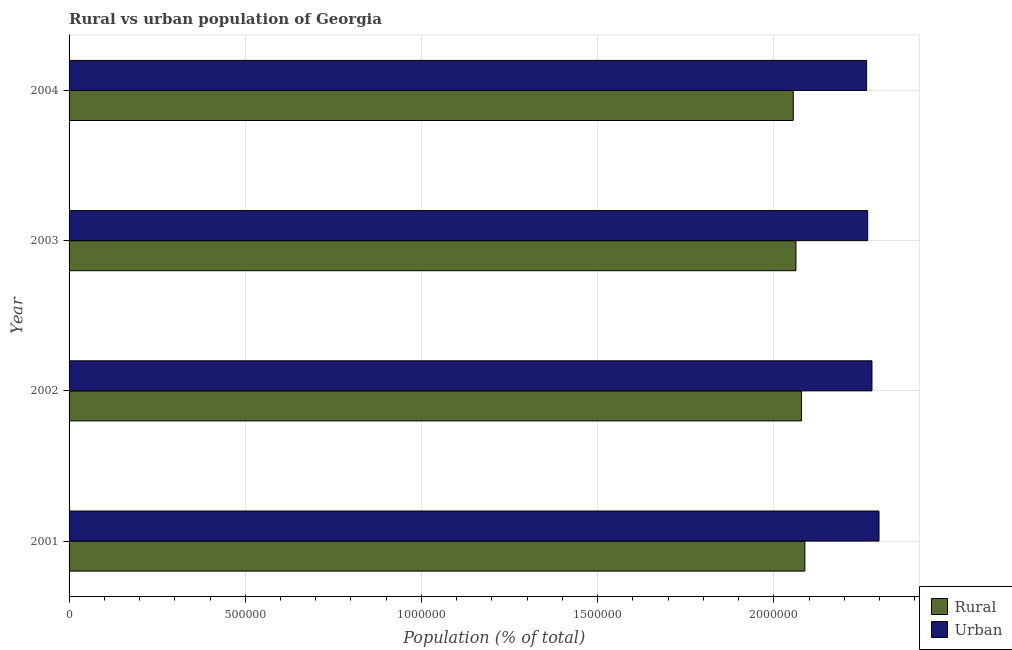How many groups of bars are there?
Provide a short and direct response. 4. Are the number of bars per tick equal to the number of legend labels?
Give a very brief answer. Yes. Are the number of bars on each tick of the Y-axis equal?
Your answer should be compact. Yes. How many bars are there on the 4th tick from the top?
Your response must be concise. 2. What is the rural population density in 2003?
Ensure brevity in your answer.  2.06e+06. Across all years, what is the maximum rural population density?
Provide a succinct answer. 2.09e+06. Across all years, what is the minimum urban population density?
Your answer should be compact. 2.26e+06. In which year was the urban population density maximum?
Your answer should be compact. 2001. In which year was the urban population density minimum?
Keep it short and to the point. 2004. What is the total urban population density in the graph?
Keep it short and to the point. 9.11e+06. What is the difference between the urban population density in 2002 and that in 2004?
Ensure brevity in your answer.  1.51e+04. What is the difference between the rural population density in 2004 and the urban population density in 2001?
Keep it short and to the point. -2.43e+05. What is the average urban population density per year?
Ensure brevity in your answer.  2.28e+06. In the year 2004, what is the difference between the rural population density and urban population density?
Your answer should be compact. -2.08e+05. In how many years, is the urban population density greater than 1000000 %?
Provide a short and direct response. 4. What is the ratio of the rural population density in 2001 to that in 2004?
Provide a short and direct response. 1.02. Is the urban population density in 2003 less than that in 2004?
Keep it short and to the point. No. What is the difference between the highest and the second highest rural population density?
Make the answer very short. 9420. What is the difference between the highest and the lowest rural population density?
Make the answer very short. 3.30e+04. In how many years, is the urban population density greater than the average urban population density taken over all years?
Ensure brevity in your answer.  2. Is the sum of the urban population density in 2001 and 2002 greater than the maximum rural population density across all years?
Give a very brief answer. Yes. What does the 1st bar from the top in 2002 represents?
Ensure brevity in your answer.  Urban. What does the 2nd bar from the bottom in 2002 represents?
Your response must be concise. Urban. How many bars are there?
Provide a succinct answer. 8. What is the difference between two consecutive major ticks on the X-axis?
Ensure brevity in your answer.  5.00e+05. Are the values on the major ticks of X-axis written in scientific E-notation?
Your answer should be very brief. No. Does the graph contain any zero values?
Give a very brief answer. No. How many legend labels are there?
Offer a terse response. 2. What is the title of the graph?
Offer a terse response. Rural vs urban population of Georgia. What is the label or title of the X-axis?
Provide a short and direct response. Population (% of total). What is the label or title of the Y-axis?
Ensure brevity in your answer.  Year. What is the Population (% of total) of Rural in 2001?
Make the answer very short. 2.09e+06. What is the Population (% of total) in Urban in 2001?
Provide a succinct answer. 2.30e+06. What is the Population (% of total) in Rural in 2002?
Offer a terse response. 2.08e+06. What is the Population (% of total) in Urban in 2002?
Give a very brief answer. 2.28e+06. What is the Population (% of total) in Rural in 2003?
Offer a terse response. 2.06e+06. What is the Population (% of total) in Urban in 2003?
Offer a very short reply. 2.27e+06. What is the Population (% of total) in Rural in 2004?
Ensure brevity in your answer.  2.06e+06. What is the Population (% of total) of Urban in 2004?
Give a very brief answer. 2.26e+06. Across all years, what is the maximum Population (% of total) in Rural?
Provide a succinct answer. 2.09e+06. Across all years, what is the maximum Population (% of total) of Urban?
Ensure brevity in your answer.  2.30e+06. Across all years, what is the minimum Population (% of total) in Rural?
Provide a short and direct response. 2.06e+06. Across all years, what is the minimum Population (% of total) in Urban?
Provide a succinct answer. 2.26e+06. What is the total Population (% of total) of Rural in the graph?
Give a very brief answer. 8.28e+06. What is the total Population (% of total) of Urban in the graph?
Your answer should be very brief. 9.11e+06. What is the difference between the Population (% of total) in Rural in 2001 and that in 2002?
Give a very brief answer. 9420. What is the difference between the Population (% of total) in Urban in 2001 and that in 2002?
Provide a short and direct response. 2.00e+04. What is the difference between the Population (% of total) of Rural in 2001 and that in 2003?
Provide a succinct answer. 2.54e+04. What is the difference between the Population (% of total) of Urban in 2001 and that in 2003?
Make the answer very short. 3.21e+04. What is the difference between the Population (% of total) of Rural in 2001 and that in 2004?
Your answer should be very brief. 3.30e+04. What is the difference between the Population (% of total) of Urban in 2001 and that in 2004?
Offer a very short reply. 3.51e+04. What is the difference between the Population (% of total) of Rural in 2002 and that in 2003?
Your answer should be very brief. 1.60e+04. What is the difference between the Population (% of total) in Urban in 2002 and that in 2003?
Your response must be concise. 1.21e+04. What is the difference between the Population (% of total) in Rural in 2002 and that in 2004?
Your answer should be very brief. 2.36e+04. What is the difference between the Population (% of total) in Urban in 2002 and that in 2004?
Offer a very short reply. 1.51e+04. What is the difference between the Population (% of total) in Rural in 2003 and that in 2004?
Give a very brief answer. 7598. What is the difference between the Population (% of total) of Urban in 2003 and that in 2004?
Provide a succinct answer. 3002. What is the difference between the Population (% of total) in Rural in 2001 and the Population (% of total) in Urban in 2002?
Provide a succinct answer. -1.90e+05. What is the difference between the Population (% of total) of Rural in 2001 and the Population (% of total) of Urban in 2003?
Your response must be concise. -1.78e+05. What is the difference between the Population (% of total) in Rural in 2001 and the Population (% of total) in Urban in 2004?
Give a very brief answer. -1.75e+05. What is the difference between the Population (% of total) of Rural in 2002 and the Population (% of total) of Urban in 2003?
Your answer should be very brief. -1.88e+05. What is the difference between the Population (% of total) in Rural in 2002 and the Population (% of total) in Urban in 2004?
Provide a short and direct response. -1.85e+05. What is the difference between the Population (% of total) of Rural in 2003 and the Population (% of total) of Urban in 2004?
Keep it short and to the point. -2.01e+05. What is the average Population (% of total) of Rural per year?
Offer a terse response. 2.07e+06. What is the average Population (% of total) of Urban per year?
Your response must be concise. 2.28e+06. In the year 2001, what is the difference between the Population (% of total) of Rural and Population (% of total) of Urban?
Your answer should be very brief. -2.10e+05. In the year 2002, what is the difference between the Population (% of total) in Rural and Population (% of total) in Urban?
Provide a succinct answer. -2.00e+05. In the year 2003, what is the difference between the Population (% of total) of Rural and Population (% of total) of Urban?
Ensure brevity in your answer.  -2.04e+05. In the year 2004, what is the difference between the Population (% of total) in Rural and Population (% of total) in Urban?
Make the answer very short. -2.08e+05. What is the ratio of the Population (% of total) of Urban in 2001 to that in 2002?
Offer a very short reply. 1.01. What is the ratio of the Population (% of total) in Rural in 2001 to that in 2003?
Ensure brevity in your answer.  1.01. What is the ratio of the Population (% of total) in Urban in 2001 to that in 2003?
Give a very brief answer. 1.01. What is the ratio of the Population (% of total) of Urban in 2001 to that in 2004?
Keep it short and to the point. 1.02. What is the ratio of the Population (% of total) in Rural in 2002 to that in 2003?
Offer a very short reply. 1.01. What is the ratio of the Population (% of total) of Urban in 2002 to that in 2003?
Your answer should be compact. 1.01. What is the ratio of the Population (% of total) of Rural in 2002 to that in 2004?
Provide a succinct answer. 1.01. What is the ratio of the Population (% of total) in Rural in 2003 to that in 2004?
Offer a terse response. 1. What is the ratio of the Population (% of total) of Urban in 2003 to that in 2004?
Give a very brief answer. 1. What is the difference between the highest and the second highest Population (% of total) of Rural?
Your answer should be very brief. 9420. What is the difference between the highest and the second highest Population (% of total) of Urban?
Provide a succinct answer. 2.00e+04. What is the difference between the highest and the lowest Population (% of total) of Rural?
Offer a terse response. 3.30e+04. What is the difference between the highest and the lowest Population (% of total) in Urban?
Offer a terse response. 3.51e+04. 